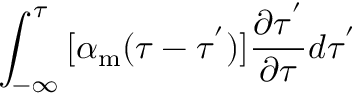Convert formula to latex. <formula><loc_0><loc_0><loc_500><loc_500>\int _ { - \infty } ^ { \tau } { [ \alpha _ { m } ( \tau - \tau ^ { ^ { \prime } } ) ] \frac { \partial \tau ^ { ^ { \prime } } } { \partial \tau } } d \tau ^ { ^ { \prime } }</formula> 